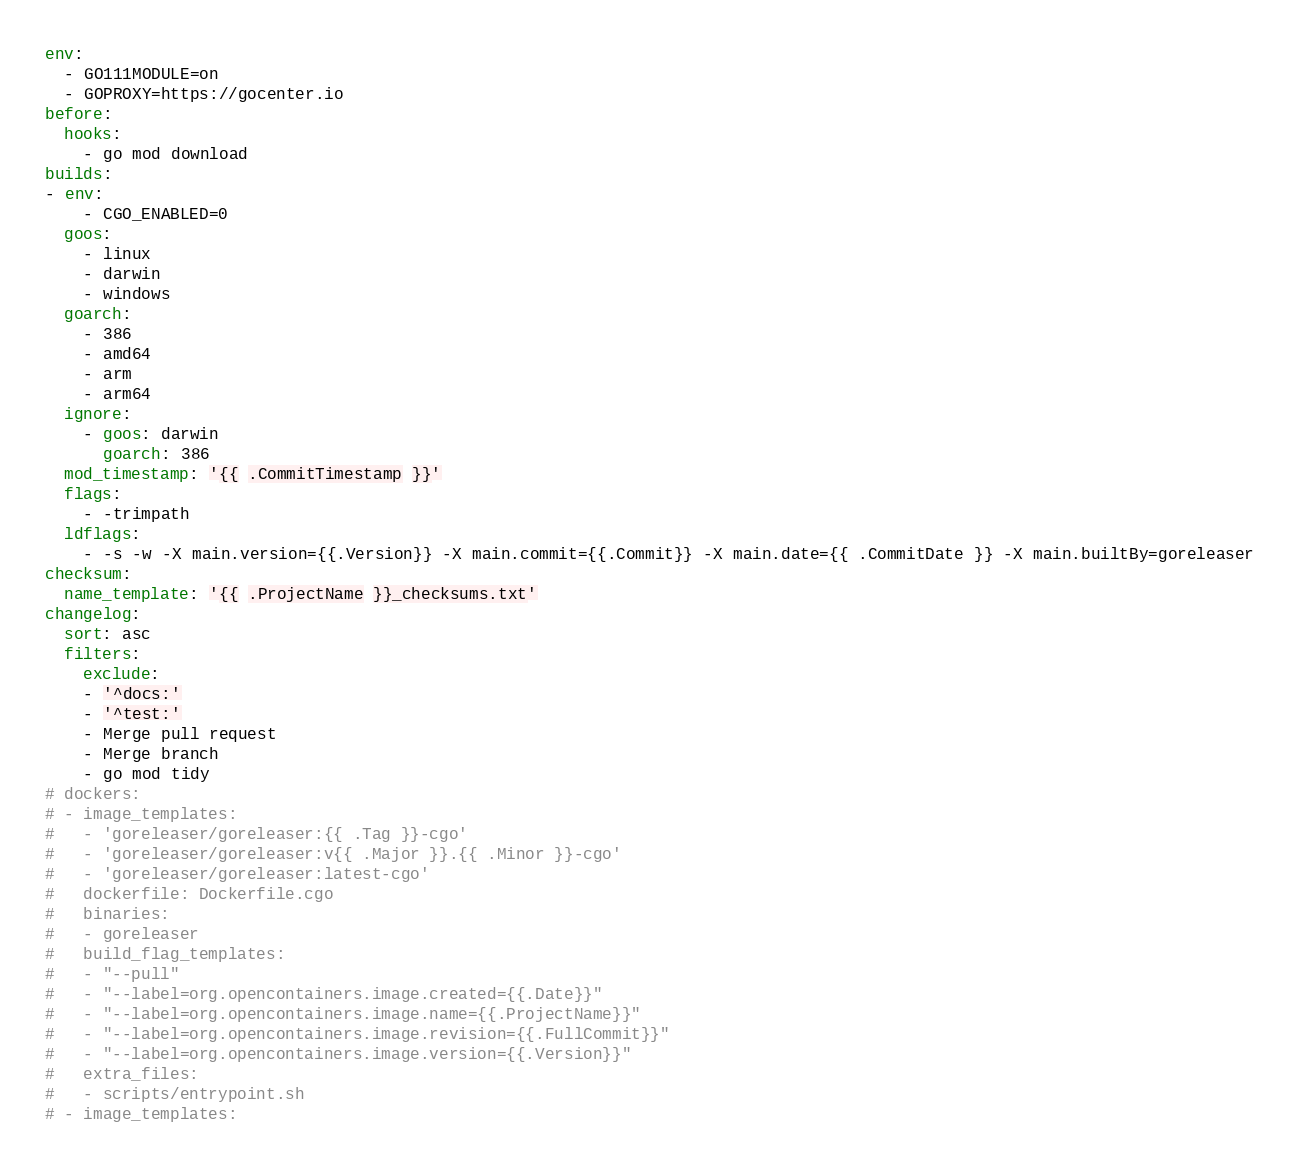Convert code to text. <code><loc_0><loc_0><loc_500><loc_500><_YAML_>env:
  - GO111MODULE=on
  - GOPROXY=https://gocenter.io
before:
  hooks:
    - go mod download
builds:
- env:
    - CGO_ENABLED=0
  goos:
    - linux
    - darwin
    - windows
  goarch:
    - 386
    - amd64
    - arm
    - arm64
  ignore:
    - goos: darwin
      goarch: 386
  mod_timestamp: '{{ .CommitTimestamp }}'
  flags:
    - -trimpath
  ldflags:
    - -s -w -X main.version={{.Version}} -X main.commit={{.Commit}} -X main.date={{ .CommitDate }} -X main.builtBy=goreleaser
checksum:
  name_template: '{{ .ProjectName }}_checksums.txt'
changelog:
  sort: asc
  filters:
    exclude:
    - '^docs:'
    - '^test:'
    - Merge pull request
    - Merge branch
    - go mod tidy
# dockers:
# - image_templates:
#   - 'goreleaser/goreleaser:{{ .Tag }}-cgo'
#   - 'goreleaser/goreleaser:v{{ .Major }}.{{ .Minor }}-cgo'
#   - 'goreleaser/goreleaser:latest-cgo'
#   dockerfile: Dockerfile.cgo
#   binaries:
#   - goreleaser
#   build_flag_templates:
#   - "--pull"
#   - "--label=org.opencontainers.image.created={{.Date}}"
#   - "--label=org.opencontainers.image.name={{.ProjectName}}"
#   - "--label=org.opencontainers.image.revision={{.FullCommit}}"
#   - "--label=org.opencontainers.image.version={{.Version}}"
#   extra_files:
#   - scripts/entrypoint.sh
# - image_templates:</code> 